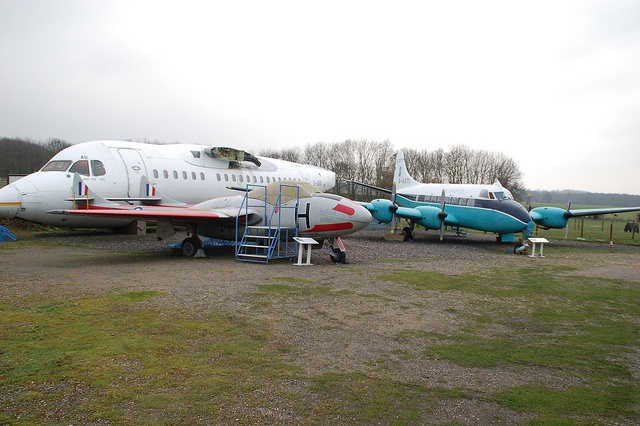Describe the objects in this image and their specific colors. I can see airplane in lightgray, darkgray, black, and gray tones and airplane in lightgray, black, teal, and gray tones in this image. 